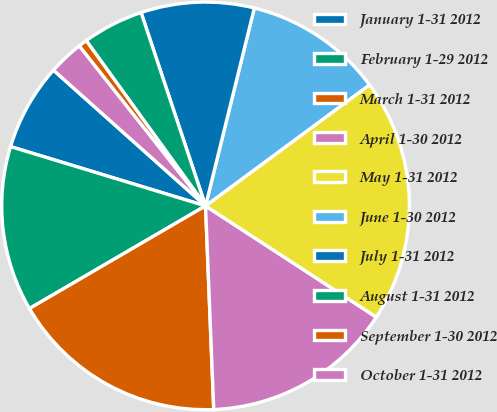Convert chart to OTSL. <chart><loc_0><loc_0><loc_500><loc_500><pie_chart><fcel>January 1-31 2012<fcel>February 1-29 2012<fcel>March 1-31 2012<fcel>April 1-30 2012<fcel>May 1-31 2012<fcel>June 1-30 2012<fcel>July 1-31 2012<fcel>August 1-31 2012<fcel>September 1-30 2012<fcel>October 1-31 2012<nl><fcel>6.9%<fcel>13.1%<fcel>17.24%<fcel>15.17%<fcel>19.31%<fcel>11.03%<fcel>8.97%<fcel>4.83%<fcel>0.69%<fcel>2.76%<nl></chart> 